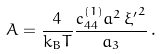Convert formula to latex. <formula><loc_0><loc_0><loc_500><loc_500>A = \frac { 4 } { k _ { B } T } \frac { c ^ { ( 1 ) } _ { 4 4 } a ^ { 2 } \, { \xi ^ { \prime } } ^ { 2 } } { a _ { 3 } } \, .</formula> 